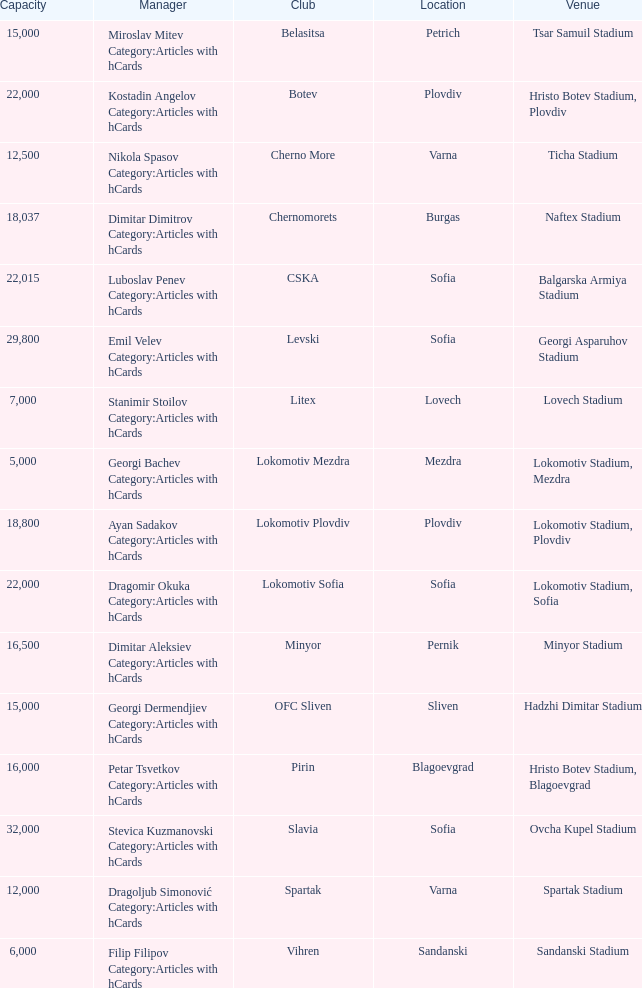What is the total number of capacity for the venue of the club, pirin? 1.0. 